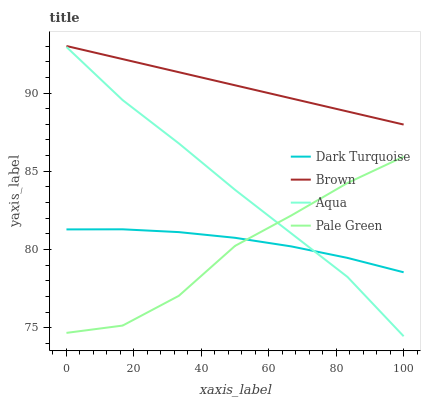Does Pale Green have the minimum area under the curve?
Answer yes or no. Yes. Does Brown have the maximum area under the curve?
Answer yes or no. Yes. Does Aqua have the minimum area under the curve?
Answer yes or no. No. Does Aqua have the maximum area under the curve?
Answer yes or no. No. Is Brown the smoothest?
Answer yes or no. Yes. Is Pale Green the roughest?
Answer yes or no. Yes. Is Aqua the smoothest?
Answer yes or no. No. Is Aqua the roughest?
Answer yes or no. No. Does Aqua have the lowest value?
Answer yes or no. Yes. Does Pale Green have the lowest value?
Answer yes or no. No. Does Brown have the highest value?
Answer yes or no. Yes. Does Pale Green have the highest value?
Answer yes or no. No. Is Aqua less than Brown?
Answer yes or no. Yes. Is Brown greater than Aqua?
Answer yes or no. Yes. Does Dark Turquoise intersect Aqua?
Answer yes or no. Yes. Is Dark Turquoise less than Aqua?
Answer yes or no. No. Is Dark Turquoise greater than Aqua?
Answer yes or no. No. Does Aqua intersect Brown?
Answer yes or no. No. 